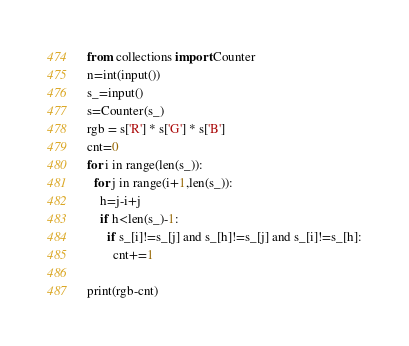<code> <loc_0><loc_0><loc_500><loc_500><_Python_>from collections import Counter
n=int(input())
s_=input()
s=Counter(s_)
rgb = s['R'] * s['G'] * s['B']
cnt=0
for i in range(len(s_)):
  for j in range(i+1,len(s_)):
    h=j-i+j
    if h<len(s_)-1:
      if s_[i]!=s_[j] and s_[h]!=s_[j] and s_[i]!=s_[h]:
        cnt+=1

print(rgb-cnt)</code> 